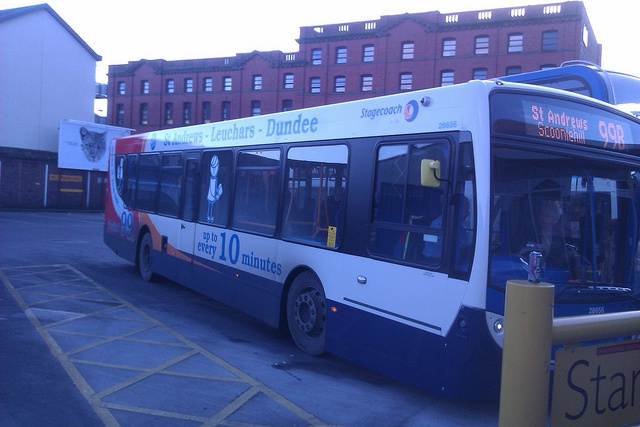Describe the objects in this image and their specific colors. I can see bus in white, navy, lightblue, and blue tones, bus in white, blue, and lightblue tones, people in white, navy, blue, and darkblue tones, people in white, navy, darkblue, blue, and gray tones, and people in white, navy, purple, and black tones in this image. 